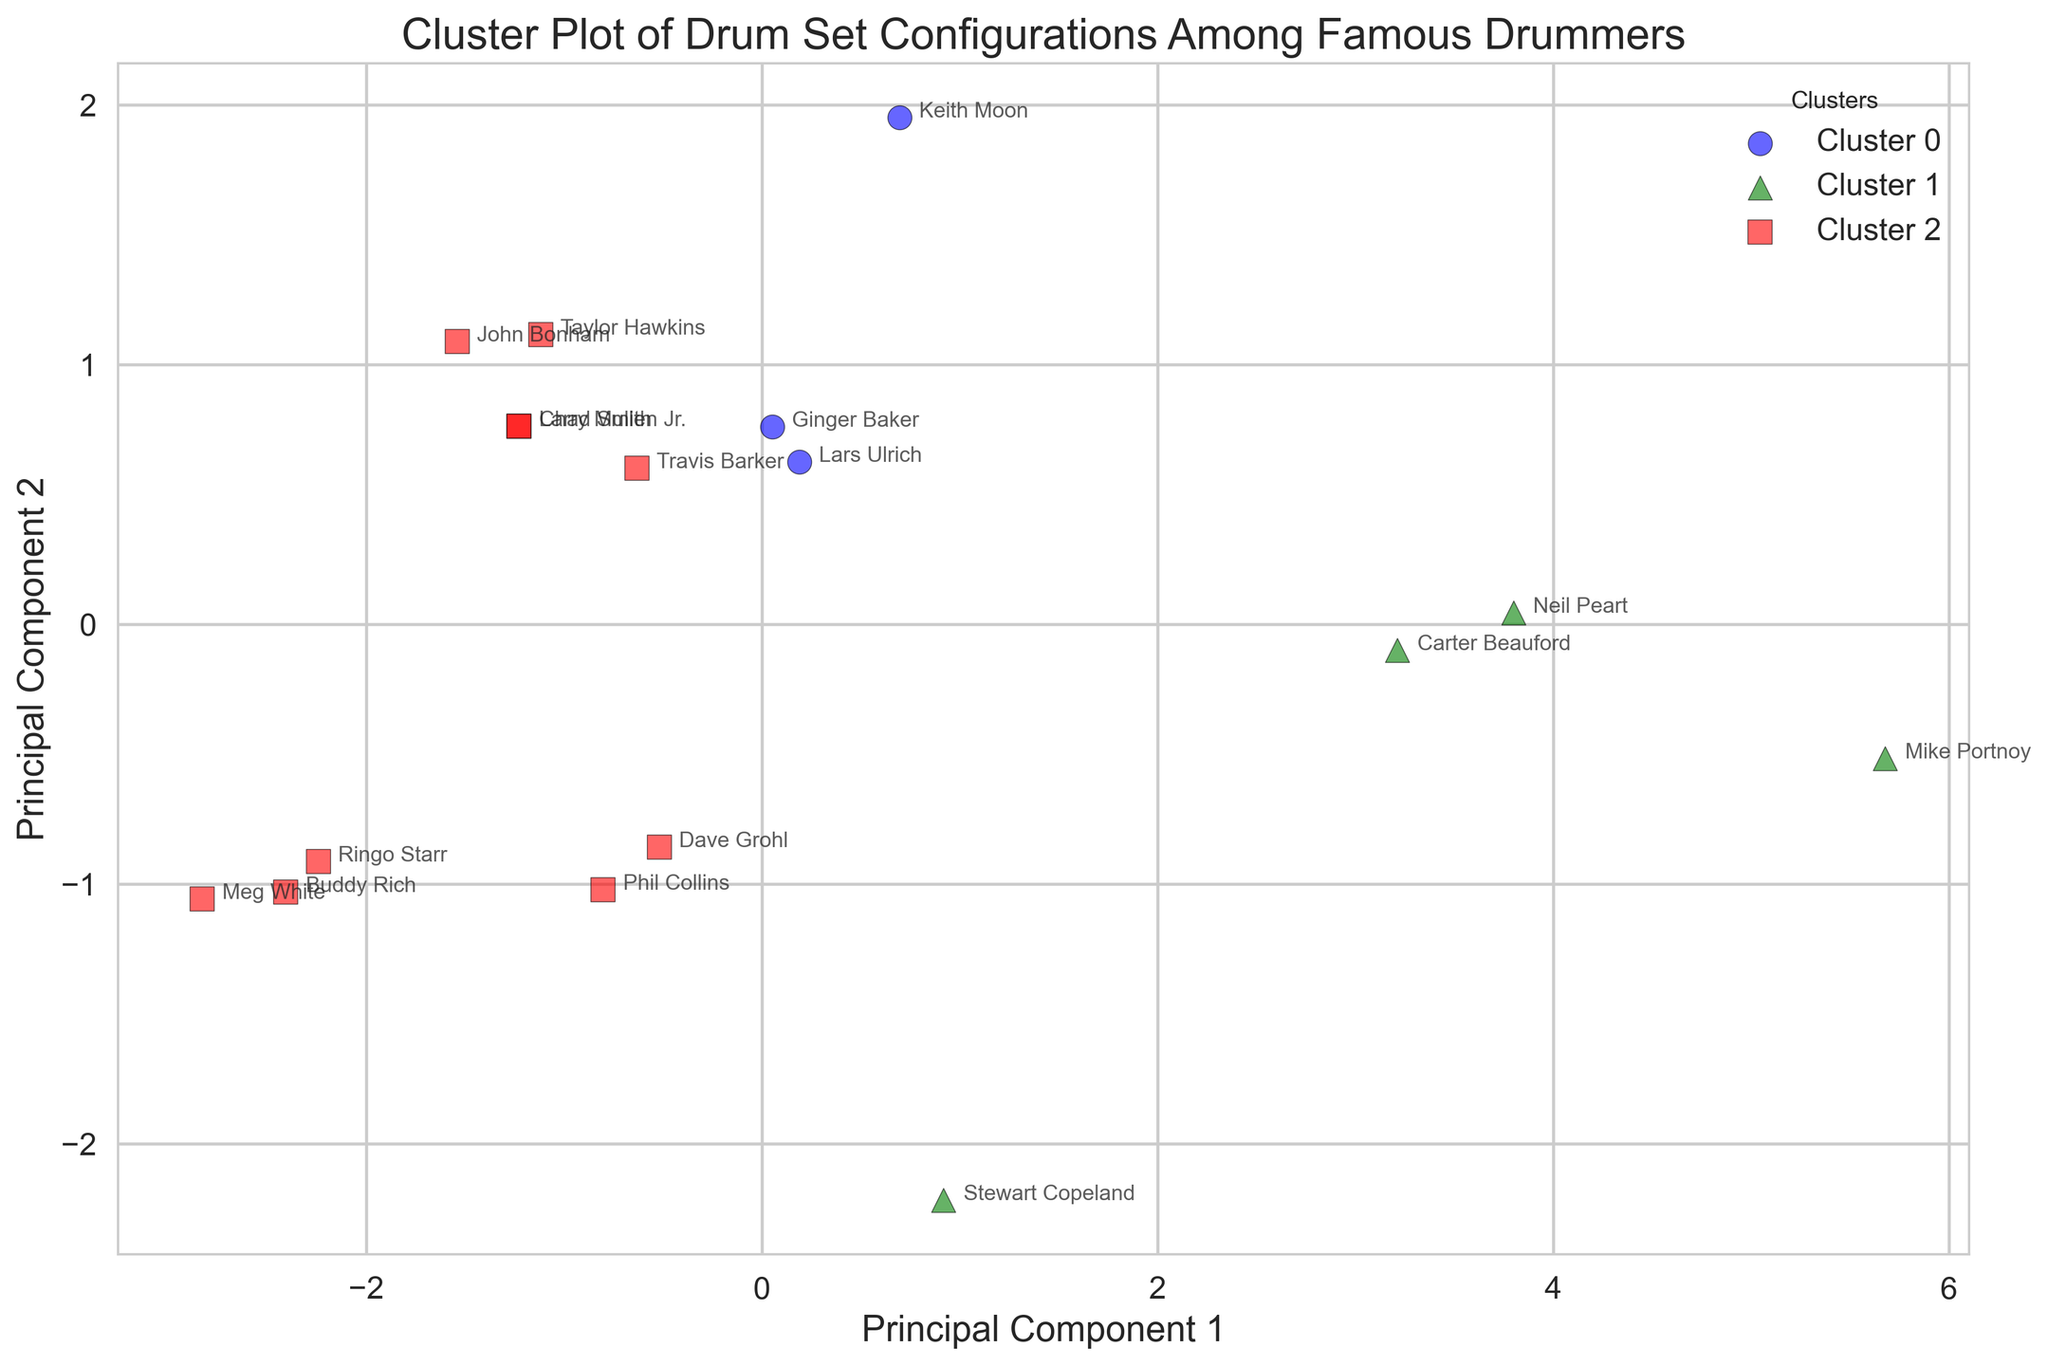Which cluster is Larry Mullen Jr. in? Identify where Larry Mullen Jr.'s name is annotated in the plot and observe the color of the marker and the cluster label. Larry Mullen Jr. is in the cluster with a specific color and marker shape.
Answer: Cluster {color}, i.e., Cluster {number} Which cluster contains the most drummers? Count the number of drummers in each cluster by observing the annotations and their respective cluster markers. The cluster with the most annotations contains the most drummers.
Answer: Cluster {number} Which principal component shows a wider spread of data points? Compare the range of values (spread) on both the PC1 (x-axis) and PC2 (y-axis). The component with the wider spread (larger range) will be more evident visually.
Answer: PC{number} How many drummers fall into Cluster 2? Identify the labels and colors associated with Cluster 2 in the legend. Then count the number of data points (drummers) marked with these attributes.
Answer: {number} Who are the outliers in the cluster plot? Look for data points that are visually distant from the main groupings of points. These outliers will typically be far from the cluster centroids and other data points.
Answer: Drummer names detected What is the average PC1 value for drummers in Cluster 1? Extract the PC1 values for all drummers in Cluster 1, sum them up and divide by the total number of drummers in Cluster 1. You may have to estimate the values from the plot.
Answer: {average PC1 value} Are drummers in Cluster 1 generally closer to the PC1 axis or the PC2 axis? Observe the relative position of Cluster 1 data points with respect to the PC1 and PC2 axes. Determine whether they are more spread out along the PC1 axis or the PC2 axis.
Answer: Closer to {PC1 / PC2} Which drummer is closest to the origin of the plot? Identify the data point that is nearest to the coordinates (0, 0) for both PC1 and PC2, indicating the origin of the plot.
Answer: Drummer name Do more drummers tend to use multiple toms compared to fewer toms? Evaluate the distribution within each cluster and consider patterns that show drummers with multiple toms. Relate this distribution back to the number of clusters and their membership.
Answer: Answer based on distribution Are there any clusters that have the same number of drummers? Compare the number of data points in each cluster and check if any clusters have an equal count.
Answer: Yes/No 